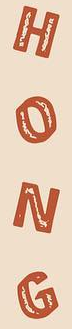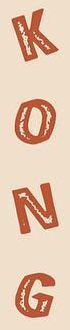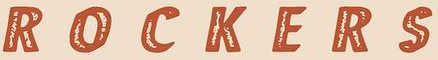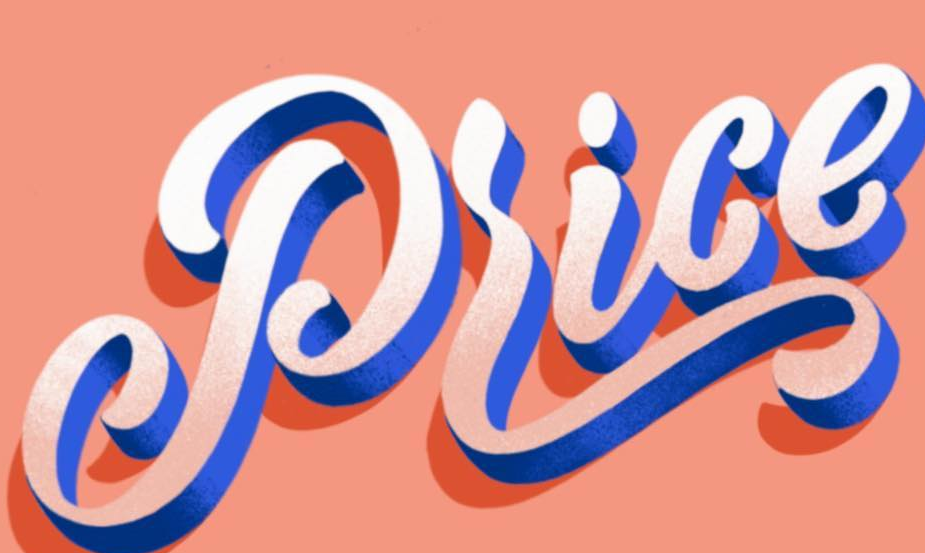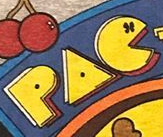Identify the words shown in these images in order, separated by a semicolon. HONG; KONG; ROCKERS; Price; PAC 